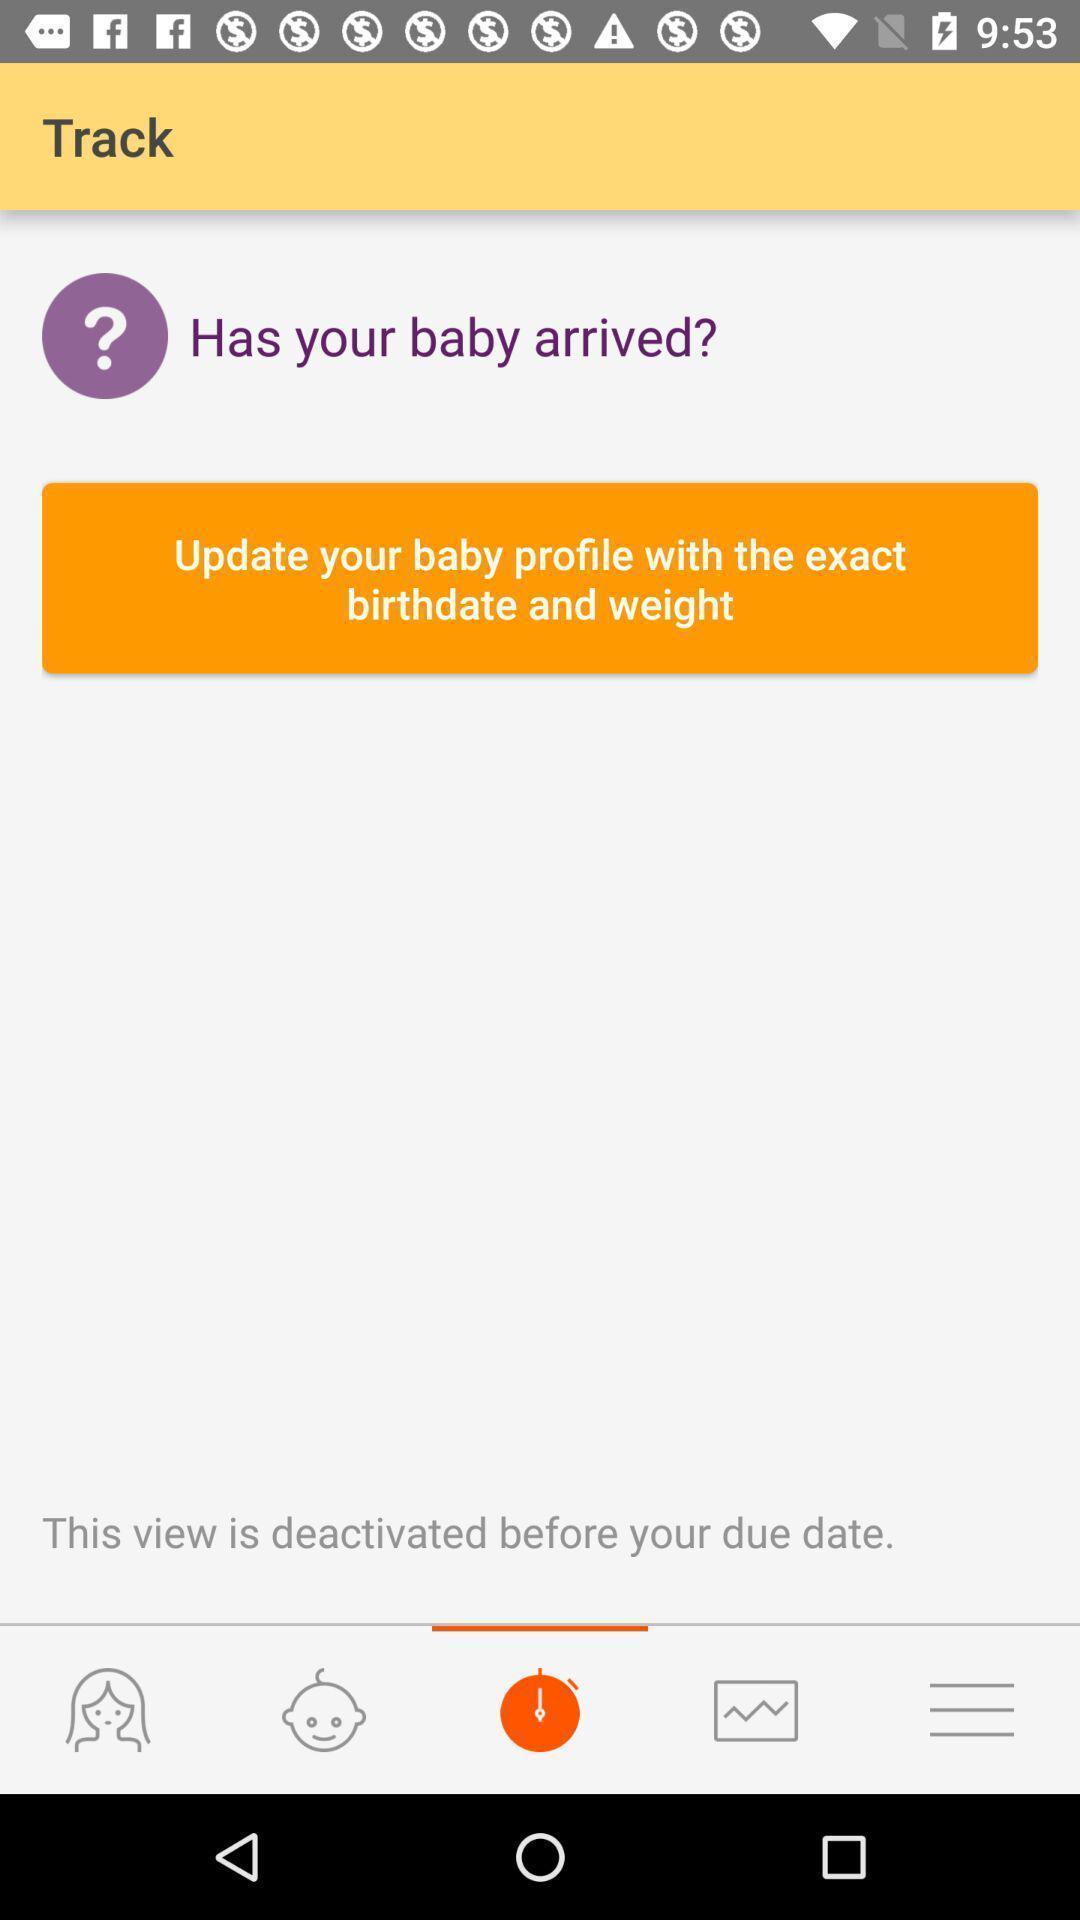Summarize the information in this screenshot. Page with instructions on updating details on baby care app. 